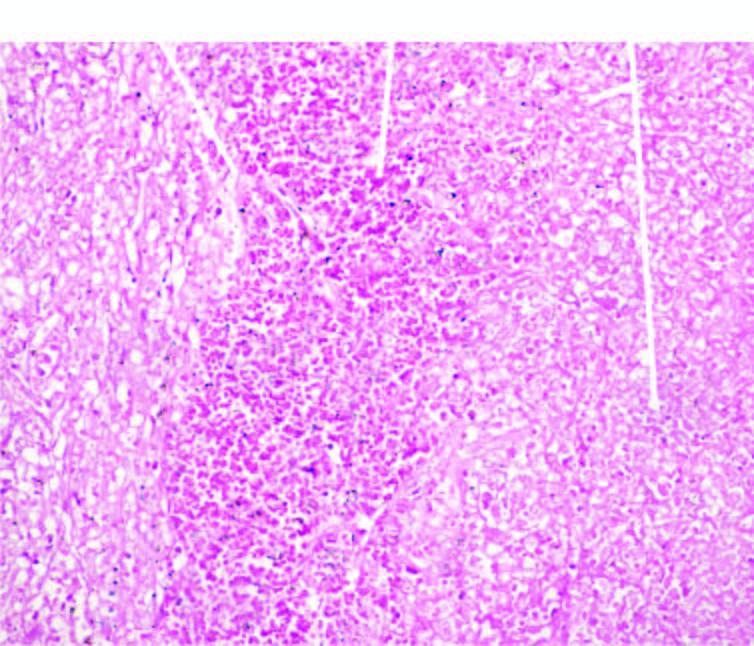what does the margin of infracted area show?
Answer the question using a single word or phrase. Haemorrhage 